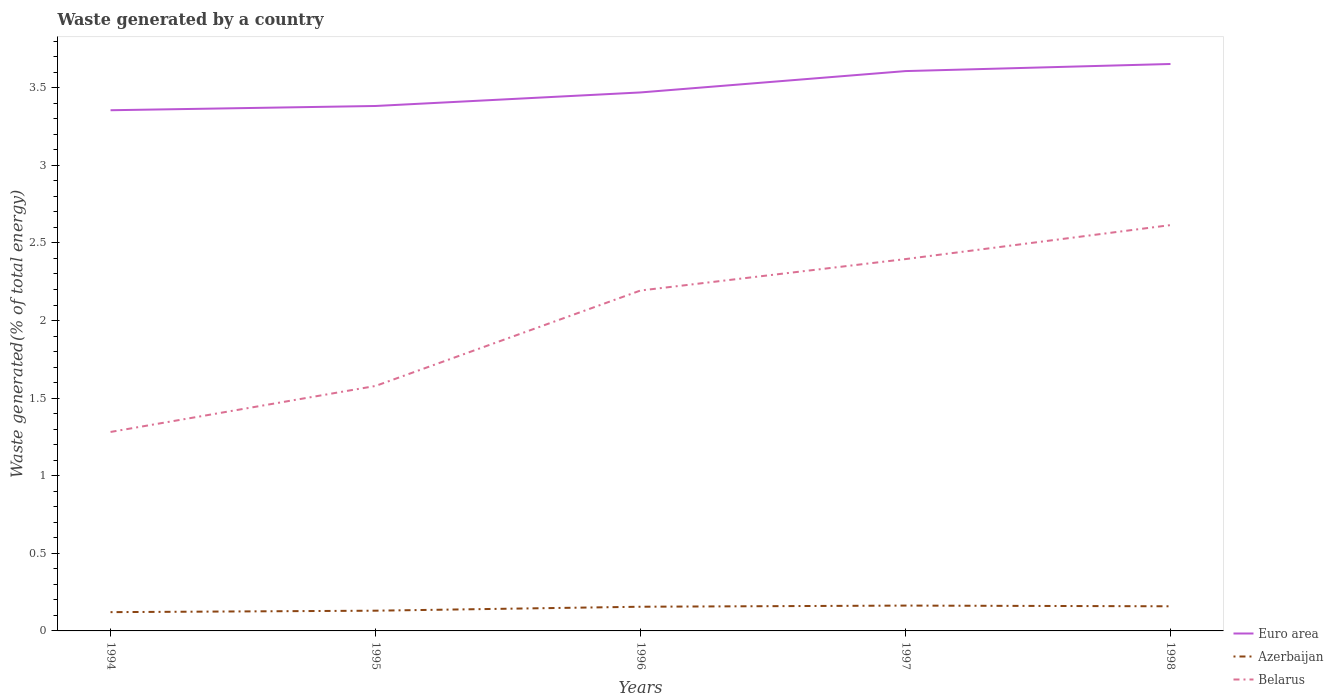Across all years, what is the maximum total waste generated in Azerbaijan?
Offer a terse response. 0.12. What is the total total waste generated in Euro area in the graph?
Offer a terse response. -0.22. What is the difference between the highest and the second highest total waste generated in Euro area?
Give a very brief answer. 0.3. How many lines are there?
Your response must be concise. 3. What is the difference between two consecutive major ticks on the Y-axis?
Offer a terse response. 0.5. Are the values on the major ticks of Y-axis written in scientific E-notation?
Offer a very short reply. No. Does the graph contain grids?
Ensure brevity in your answer.  No. How many legend labels are there?
Offer a terse response. 3. What is the title of the graph?
Ensure brevity in your answer.  Waste generated by a country. What is the label or title of the Y-axis?
Provide a short and direct response. Waste generated(% of total energy). What is the Waste generated(% of total energy) in Euro area in 1994?
Your answer should be compact. 3.35. What is the Waste generated(% of total energy) of Azerbaijan in 1994?
Make the answer very short. 0.12. What is the Waste generated(% of total energy) of Belarus in 1994?
Ensure brevity in your answer.  1.28. What is the Waste generated(% of total energy) in Euro area in 1995?
Your answer should be very brief. 3.38. What is the Waste generated(% of total energy) in Azerbaijan in 1995?
Make the answer very short. 0.13. What is the Waste generated(% of total energy) of Belarus in 1995?
Offer a terse response. 1.58. What is the Waste generated(% of total energy) in Euro area in 1996?
Make the answer very short. 3.47. What is the Waste generated(% of total energy) in Azerbaijan in 1996?
Ensure brevity in your answer.  0.16. What is the Waste generated(% of total energy) in Belarus in 1996?
Keep it short and to the point. 2.19. What is the Waste generated(% of total energy) in Euro area in 1997?
Offer a very short reply. 3.61. What is the Waste generated(% of total energy) of Azerbaijan in 1997?
Offer a terse response. 0.16. What is the Waste generated(% of total energy) in Belarus in 1997?
Ensure brevity in your answer.  2.4. What is the Waste generated(% of total energy) of Euro area in 1998?
Your response must be concise. 3.65. What is the Waste generated(% of total energy) of Azerbaijan in 1998?
Your response must be concise. 0.16. What is the Waste generated(% of total energy) of Belarus in 1998?
Offer a very short reply. 2.61. Across all years, what is the maximum Waste generated(% of total energy) of Euro area?
Your answer should be very brief. 3.65. Across all years, what is the maximum Waste generated(% of total energy) of Azerbaijan?
Provide a succinct answer. 0.16. Across all years, what is the maximum Waste generated(% of total energy) in Belarus?
Keep it short and to the point. 2.61. Across all years, what is the minimum Waste generated(% of total energy) in Euro area?
Your answer should be very brief. 3.35. Across all years, what is the minimum Waste generated(% of total energy) in Azerbaijan?
Offer a very short reply. 0.12. Across all years, what is the minimum Waste generated(% of total energy) in Belarus?
Offer a very short reply. 1.28. What is the total Waste generated(% of total energy) of Euro area in the graph?
Ensure brevity in your answer.  17.47. What is the total Waste generated(% of total energy) of Azerbaijan in the graph?
Your answer should be compact. 0.73. What is the total Waste generated(% of total energy) of Belarus in the graph?
Give a very brief answer. 10.06. What is the difference between the Waste generated(% of total energy) of Euro area in 1994 and that in 1995?
Ensure brevity in your answer.  -0.03. What is the difference between the Waste generated(% of total energy) of Azerbaijan in 1994 and that in 1995?
Offer a terse response. -0.01. What is the difference between the Waste generated(% of total energy) of Belarus in 1994 and that in 1995?
Your answer should be very brief. -0.3. What is the difference between the Waste generated(% of total energy) in Euro area in 1994 and that in 1996?
Your answer should be compact. -0.11. What is the difference between the Waste generated(% of total energy) in Azerbaijan in 1994 and that in 1996?
Keep it short and to the point. -0.03. What is the difference between the Waste generated(% of total energy) in Belarus in 1994 and that in 1996?
Your answer should be compact. -0.91. What is the difference between the Waste generated(% of total energy) of Euro area in 1994 and that in 1997?
Ensure brevity in your answer.  -0.25. What is the difference between the Waste generated(% of total energy) in Azerbaijan in 1994 and that in 1997?
Make the answer very short. -0.04. What is the difference between the Waste generated(% of total energy) in Belarus in 1994 and that in 1997?
Your response must be concise. -1.11. What is the difference between the Waste generated(% of total energy) in Euro area in 1994 and that in 1998?
Your answer should be compact. -0.3. What is the difference between the Waste generated(% of total energy) of Azerbaijan in 1994 and that in 1998?
Keep it short and to the point. -0.04. What is the difference between the Waste generated(% of total energy) of Belarus in 1994 and that in 1998?
Your response must be concise. -1.33. What is the difference between the Waste generated(% of total energy) in Euro area in 1995 and that in 1996?
Offer a very short reply. -0.09. What is the difference between the Waste generated(% of total energy) of Azerbaijan in 1995 and that in 1996?
Provide a succinct answer. -0.03. What is the difference between the Waste generated(% of total energy) of Belarus in 1995 and that in 1996?
Offer a very short reply. -0.61. What is the difference between the Waste generated(% of total energy) in Euro area in 1995 and that in 1997?
Your answer should be compact. -0.22. What is the difference between the Waste generated(% of total energy) of Azerbaijan in 1995 and that in 1997?
Offer a very short reply. -0.03. What is the difference between the Waste generated(% of total energy) in Belarus in 1995 and that in 1997?
Offer a very short reply. -0.82. What is the difference between the Waste generated(% of total energy) in Euro area in 1995 and that in 1998?
Ensure brevity in your answer.  -0.27. What is the difference between the Waste generated(% of total energy) of Azerbaijan in 1995 and that in 1998?
Offer a terse response. -0.03. What is the difference between the Waste generated(% of total energy) in Belarus in 1995 and that in 1998?
Make the answer very short. -1.04. What is the difference between the Waste generated(% of total energy) in Euro area in 1996 and that in 1997?
Provide a succinct answer. -0.14. What is the difference between the Waste generated(% of total energy) in Azerbaijan in 1996 and that in 1997?
Ensure brevity in your answer.  -0.01. What is the difference between the Waste generated(% of total energy) of Belarus in 1996 and that in 1997?
Keep it short and to the point. -0.2. What is the difference between the Waste generated(% of total energy) in Euro area in 1996 and that in 1998?
Make the answer very short. -0.18. What is the difference between the Waste generated(% of total energy) of Azerbaijan in 1996 and that in 1998?
Ensure brevity in your answer.  -0. What is the difference between the Waste generated(% of total energy) of Belarus in 1996 and that in 1998?
Offer a very short reply. -0.42. What is the difference between the Waste generated(% of total energy) of Euro area in 1997 and that in 1998?
Offer a very short reply. -0.05. What is the difference between the Waste generated(% of total energy) in Azerbaijan in 1997 and that in 1998?
Make the answer very short. 0. What is the difference between the Waste generated(% of total energy) of Belarus in 1997 and that in 1998?
Provide a succinct answer. -0.22. What is the difference between the Waste generated(% of total energy) of Euro area in 1994 and the Waste generated(% of total energy) of Azerbaijan in 1995?
Give a very brief answer. 3.22. What is the difference between the Waste generated(% of total energy) of Euro area in 1994 and the Waste generated(% of total energy) of Belarus in 1995?
Your answer should be compact. 1.78. What is the difference between the Waste generated(% of total energy) in Azerbaijan in 1994 and the Waste generated(% of total energy) in Belarus in 1995?
Offer a terse response. -1.46. What is the difference between the Waste generated(% of total energy) of Euro area in 1994 and the Waste generated(% of total energy) of Azerbaijan in 1996?
Offer a very short reply. 3.2. What is the difference between the Waste generated(% of total energy) in Euro area in 1994 and the Waste generated(% of total energy) in Belarus in 1996?
Your answer should be very brief. 1.16. What is the difference between the Waste generated(% of total energy) in Azerbaijan in 1994 and the Waste generated(% of total energy) in Belarus in 1996?
Your answer should be compact. -2.07. What is the difference between the Waste generated(% of total energy) in Euro area in 1994 and the Waste generated(% of total energy) in Azerbaijan in 1997?
Provide a short and direct response. 3.19. What is the difference between the Waste generated(% of total energy) of Euro area in 1994 and the Waste generated(% of total energy) of Belarus in 1997?
Ensure brevity in your answer.  0.96. What is the difference between the Waste generated(% of total energy) of Azerbaijan in 1994 and the Waste generated(% of total energy) of Belarus in 1997?
Give a very brief answer. -2.27. What is the difference between the Waste generated(% of total energy) of Euro area in 1994 and the Waste generated(% of total energy) of Azerbaijan in 1998?
Give a very brief answer. 3.2. What is the difference between the Waste generated(% of total energy) of Euro area in 1994 and the Waste generated(% of total energy) of Belarus in 1998?
Ensure brevity in your answer.  0.74. What is the difference between the Waste generated(% of total energy) in Azerbaijan in 1994 and the Waste generated(% of total energy) in Belarus in 1998?
Provide a succinct answer. -2.49. What is the difference between the Waste generated(% of total energy) of Euro area in 1995 and the Waste generated(% of total energy) of Azerbaijan in 1996?
Give a very brief answer. 3.23. What is the difference between the Waste generated(% of total energy) of Euro area in 1995 and the Waste generated(% of total energy) of Belarus in 1996?
Offer a very short reply. 1.19. What is the difference between the Waste generated(% of total energy) in Azerbaijan in 1995 and the Waste generated(% of total energy) in Belarus in 1996?
Your answer should be compact. -2.06. What is the difference between the Waste generated(% of total energy) in Euro area in 1995 and the Waste generated(% of total energy) in Azerbaijan in 1997?
Make the answer very short. 3.22. What is the difference between the Waste generated(% of total energy) of Euro area in 1995 and the Waste generated(% of total energy) of Belarus in 1997?
Keep it short and to the point. 0.99. What is the difference between the Waste generated(% of total energy) of Azerbaijan in 1995 and the Waste generated(% of total energy) of Belarus in 1997?
Make the answer very short. -2.27. What is the difference between the Waste generated(% of total energy) in Euro area in 1995 and the Waste generated(% of total energy) in Azerbaijan in 1998?
Give a very brief answer. 3.22. What is the difference between the Waste generated(% of total energy) of Euro area in 1995 and the Waste generated(% of total energy) of Belarus in 1998?
Your response must be concise. 0.77. What is the difference between the Waste generated(% of total energy) of Azerbaijan in 1995 and the Waste generated(% of total energy) of Belarus in 1998?
Provide a succinct answer. -2.48. What is the difference between the Waste generated(% of total energy) in Euro area in 1996 and the Waste generated(% of total energy) in Azerbaijan in 1997?
Offer a terse response. 3.31. What is the difference between the Waste generated(% of total energy) in Euro area in 1996 and the Waste generated(% of total energy) in Belarus in 1997?
Provide a short and direct response. 1.07. What is the difference between the Waste generated(% of total energy) of Azerbaijan in 1996 and the Waste generated(% of total energy) of Belarus in 1997?
Your response must be concise. -2.24. What is the difference between the Waste generated(% of total energy) of Euro area in 1996 and the Waste generated(% of total energy) of Azerbaijan in 1998?
Your answer should be very brief. 3.31. What is the difference between the Waste generated(% of total energy) in Euro area in 1996 and the Waste generated(% of total energy) in Belarus in 1998?
Provide a succinct answer. 0.85. What is the difference between the Waste generated(% of total energy) of Azerbaijan in 1996 and the Waste generated(% of total energy) of Belarus in 1998?
Ensure brevity in your answer.  -2.46. What is the difference between the Waste generated(% of total energy) in Euro area in 1997 and the Waste generated(% of total energy) in Azerbaijan in 1998?
Keep it short and to the point. 3.45. What is the difference between the Waste generated(% of total energy) of Azerbaijan in 1997 and the Waste generated(% of total energy) of Belarus in 1998?
Ensure brevity in your answer.  -2.45. What is the average Waste generated(% of total energy) in Euro area per year?
Make the answer very short. 3.49. What is the average Waste generated(% of total energy) in Azerbaijan per year?
Your answer should be very brief. 0.15. What is the average Waste generated(% of total energy) in Belarus per year?
Keep it short and to the point. 2.01. In the year 1994, what is the difference between the Waste generated(% of total energy) of Euro area and Waste generated(% of total energy) of Azerbaijan?
Your answer should be compact. 3.23. In the year 1994, what is the difference between the Waste generated(% of total energy) of Euro area and Waste generated(% of total energy) of Belarus?
Provide a short and direct response. 2.07. In the year 1994, what is the difference between the Waste generated(% of total energy) of Azerbaijan and Waste generated(% of total energy) of Belarus?
Your answer should be compact. -1.16. In the year 1995, what is the difference between the Waste generated(% of total energy) in Euro area and Waste generated(% of total energy) in Azerbaijan?
Ensure brevity in your answer.  3.25. In the year 1995, what is the difference between the Waste generated(% of total energy) in Euro area and Waste generated(% of total energy) in Belarus?
Your answer should be compact. 1.8. In the year 1995, what is the difference between the Waste generated(% of total energy) in Azerbaijan and Waste generated(% of total energy) in Belarus?
Offer a terse response. -1.45. In the year 1996, what is the difference between the Waste generated(% of total energy) in Euro area and Waste generated(% of total energy) in Azerbaijan?
Your response must be concise. 3.31. In the year 1996, what is the difference between the Waste generated(% of total energy) in Euro area and Waste generated(% of total energy) in Belarus?
Your answer should be very brief. 1.28. In the year 1996, what is the difference between the Waste generated(% of total energy) in Azerbaijan and Waste generated(% of total energy) in Belarus?
Your response must be concise. -2.04. In the year 1997, what is the difference between the Waste generated(% of total energy) in Euro area and Waste generated(% of total energy) in Azerbaijan?
Give a very brief answer. 3.44. In the year 1997, what is the difference between the Waste generated(% of total energy) of Euro area and Waste generated(% of total energy) of Belarus?
Keep it short and to the point. 1.21. In the year 1997, what is the difference between the Waste generated(% of total energy) of Azerbaijan and Waste generated(% of total energy) of Belarus?
Provide a succinct answer. -2.23. In the year 1998, what is the difference between the Waste generated(% of total energy) of Euro area and Waste generated(% of total energy) of Azerbaijan?
Provide a succinct answer. 3.49. In the year 1998, what is the difference between the Waste generated(% of total energy) of Euro area and Waste generated(% of total energy) of Belarus?
Your response must be concise. 1.04. In the year 1998, what is the difference between the Waste generated(% of total energy) of Azerbaijan and Waste generated(% of total energy) of Belarus?
Your response must be concise. -2.46. What is the ratio of the Waste generated(% of total energy) in Azerbaijan in 1994 to that in 1995?
Offer a very short reply. 0.93. What is the ratio of the Waste generated(% of total energy) in Belarus in 1994 to that in 1995?
Your answer should be very brief. 0.81. What is the ratio of the Waste generated(% of total energy) in Euro area in 1994 to that in 1996?
Give a very brief answer. 0.97. What is the ratio of the Waste generated(% of total energy) of Azerbaijan in 1994 to that in 1996?
Your response must be concise. 0.78. What is the ratio of the Waste generated(% of total energy) of Belarus in 1994 to that in 1996?
Your response must be concise. 0.58. What is the ratio of the Waste generated(% of total energy) in Euro area in 1994 to that in 1997?
Keep it short and to the point. 0.93. What is the ratio of the Waste generated(% of total energy) of Azerbaijan in 1994 to that in 1997?
Ensure brevity in your answer.  0.74. What is the ratio of the Waste generated(% of total energy) in Belarus in 1994 to that in 1997?
Provide a short and direct response. 0.54. What is the ratio of the Waste generated(% of total energy) of Euro area in 1994 to that in 1998?
Make the answer very short. 0.92. What is the ratio of the Waste generated(% of total energy) of Azerbaijan in 1994 to that in 1998?
Offer a terse response. 0.76. What is the ratio of the Waste generated(% of total energy) in Belarus in 1994 to that in 1998?
Offer a very short reply. 0.49. What is the ratio of the Waste generated(% of total energy) of Euro area in 1995 to that in 1996?
Your answer should be compact. 0.97. What is the ratio of the Waste generated(% of total energy) in Azerbaijan in 1995 to that in 1996?
Provide a short and direct response. 0.84. What is the ratio of the Waste generated(% of total energy) in Belarus in 1995 to that in 1996?
Offer a very short reply. 0.72. What is the ratio of the Waste generated(% of total energy) of Euro area in 1995 to that in 1997?
Your answer should be very brief. 0.94. What is the ratio of the Waste generated(% of total energy) in Azerbaijan in 1995 to that in 1997?
Your response must be concise. 0.8. What is the ratio of the Waste generated(% of total energy) of Belarus in 1995 to that in 1997?
Your response must be concise. 0.66. What is the ratio of the Waste generated(% of total energy) in Euro area in 1995 to that in 1998?
Offer a very short reply. 0.93. What is the ratio of the Waste generated(% of total energy) in Azerbaijan in 1995 to that in 1998?
Provide a short and direct response. 0.82. What is the ratio of the Waste generated(% of total energy) of Belarus in 1995 to that in 1998?
Offer a terse response. 0.6. What is the ratio of the Waste generated(% of total energy) of Euro area in 1996 to that in 1997?
Make the answer very short. 0.96. What is the ratio of the Waste generated(% of total energy) in Azerbaijan in 1996 to that in 1997?
Provide a succinct answer. 0.95. What is the ratio of the Waste generated(% of total energy) in Belarus in 1996 to that in 1997?
Your answer should be very brief. 0.92. What is the ratio of the Waste generated(% of total energy) in Euro area in 1996 to that in 1998?
Offer a very short reply. 0.95. What is the ratio of the Waste generated(% of total energy) in Azerbaijan in 1996 to that in 1998?
Your response must be concise. 0.98. What is the ratio of the Waste generated(% of total energy) in Belarus in 1996 to that in 1998?
Provide a succinct answer. 0.84. What is the ratio of the Waste generated(% of total energy) of Euro area in 1997 to that in 1998?
Offer a terse response. 0.99. What is the ratio of the Waste generated(% of total energy) of Azerbaijan in 1997 to that in 1998?
Give a very brief answer. 1.03. What is the ratio of the Waste generated(% of total energy) of Belarus in 1997 to that in 1998?
Provide a succinct answer. 0.92. What is the difference between the highest and the second highest Waste generated(% of total energy) in Euro area?
Offer a terse response. 0.05. What is the difference between the highest and the second highest Waste generated(% of total energy) in Azerbaijan?
Provide a short and direct response. 0. What is the difference between the highest and the second highest Waste generated(% of total energy) in Belarus?
Offer a terse response. 0.22. What is the difference between the highest and the lowest Waste generated(% of total energy) of Euro area?
Your answer should be compact. 0.3. What is the difference between the highest and the lowest Waste generated(% of total energy) of Azerbaijan?
Ensure brevity in your answer.  0.04. What is the difference between the highest and the lowest Waste generated(% of total energy) of Belarus?
Ensure brevity in your answer.  1.33. 